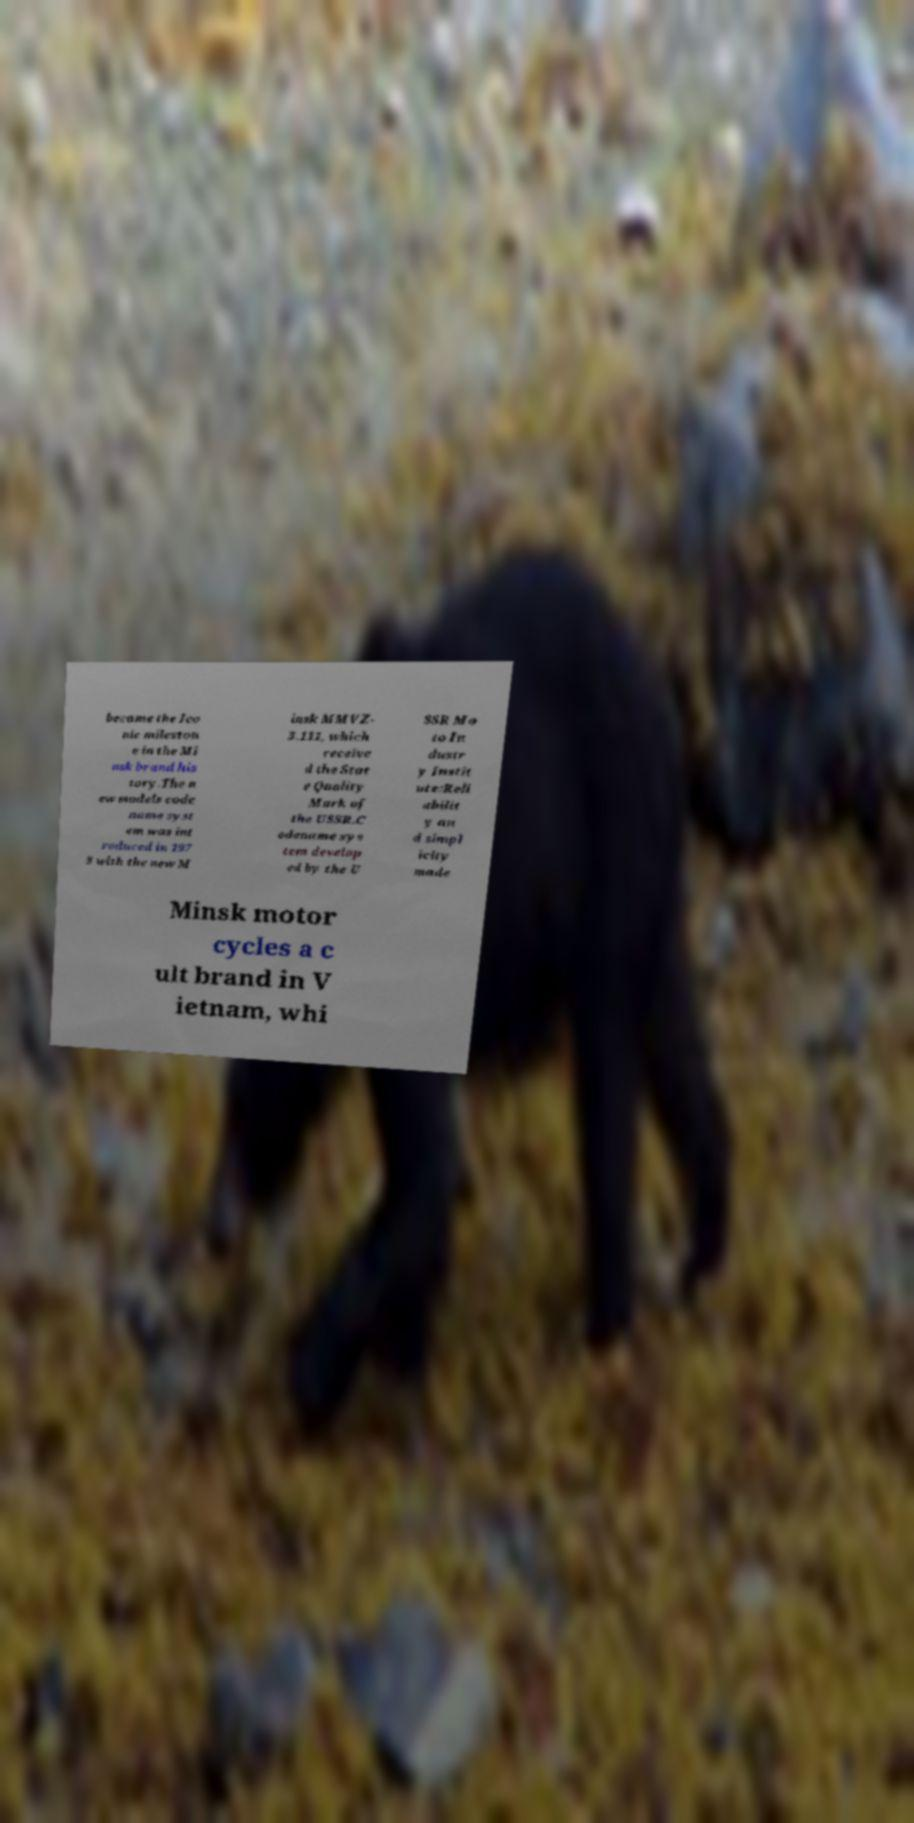Can you read and provide the text displayed in the image?This photo seems to have some interesting text. Can you extract and type it out for me? became the Ico nic mileston e in the Mi nsk brand his tory.The n ew models code name syst em was int roduced in 197 3 with the new M insk MMVZ- 3.111, which receive d the Stat e Quality Mark of the USSR.C odename sys tem develop ed by the U SSR Mo to In dustr y Instit ute:Reli abilit y an d simpl icity made Minsk motor cycles a c ult brand in V ietnam, whi 